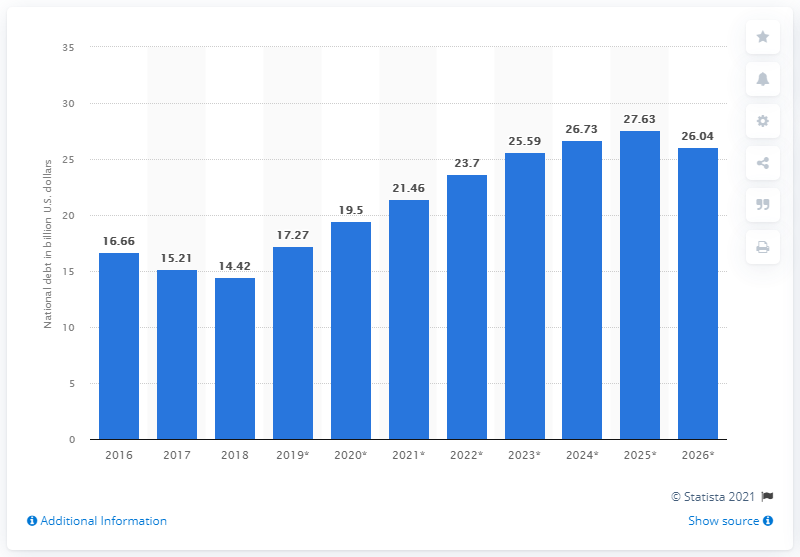Indicate a few pertinent items in this graphic. In 2018, the national debt of Iceland was 14.42 dollars. 